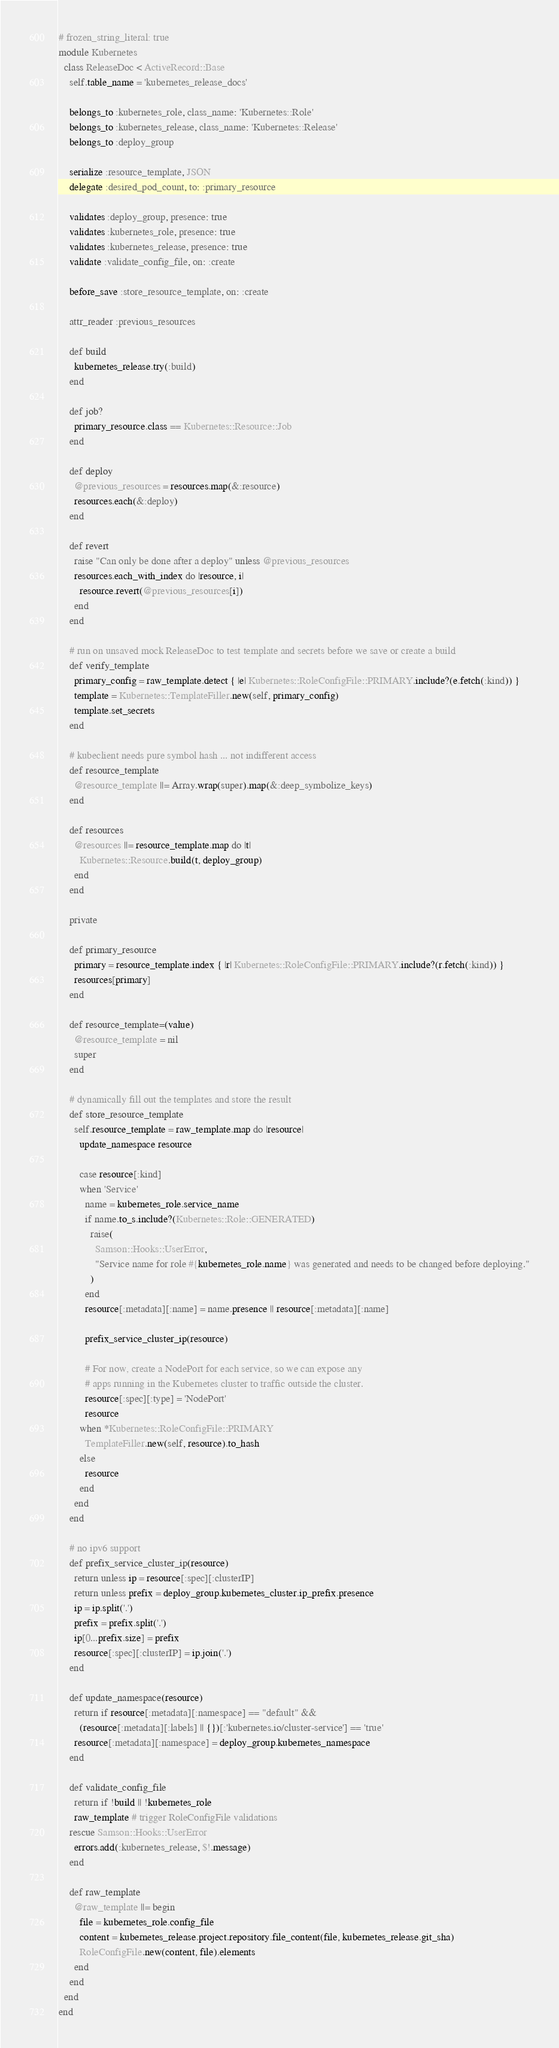Convert code to text. <code><loc_0><loc_0><loc_500><loc_500><_Ruby_># frozen_string_literal: true
module Kubernetes
  class ReleaseDoc < ActiveRecord::Base
    self.table_name = 'kubernetes_release_docs'

    belongs_to :kubernetes_role, class_name: 'Kubernetes::Role'
    belongs_to :kubernetes_release, class_name: 'Kubernetes::Release'
    belongs_to :deploy_group

    serialize :resource_template, JSON
    delegate :desired_pod_count, to: :primary_resource

    validates :deploy_group, presence: true
    validates :kubernetes_role, presence: true
    validates :kubernetes_release, presence: true
    validate :validate_config_file, on: :create

    before_save :store_resource_template, on: :create

    attr_reader :previous_resources

    def build
      kubernetes_release.try(:build)
    end

    def job?
      primary_resource.class == Kubernetes::Resource::Job
    end

    def deploy
      @previous_resources = resources.map(&:resource)
      resources.each(&:deploy)
    end

    def revert
      raise "Can only be done after a deploy" unless @previous_resources
      resources.each_with_index do |resource, i|
        resource.revert(@previous_resources[i])
      end
    end

    # run on unsaved mock ReleaseDoc to test template and secrets before we save or create a build
    def verify_template
      primary_config = raw_template.detect { |e| Kubernetes::RoleConfigFile::PRIMARY.include?(e.fetch(:kind)) }
      template = Kubernetes::TemplateFiller.new(self, primary_config)
      template.set_secrets
    end

    # kubeclient needs pure symbol hash ... not indifferent access
    def resource_template
      @resource_template ||= Array.wrap(super).map(&:deep_symbolize_keys)
    end

    def resources
      @resources ||= resource_template.map do |t|
        Kubernetes::Resource.build(t, deploy_group)
      end
    end

    private

    def primary_resource
      primary = resource_template.index { |r| Kubernetes::RoleConfigFile::PRIMARY.include?(r.fetch(:kind)) }
      resources[primary]
    end

    def resource_template=(value)
      @resource_template = nil
      super
    end

    # dynamically fill out the templates and store the result
    def store_resource_template
      self.resource_template = raw_template.map do |resource|
        update_namespace resource

        case resource[:kind]
        when 'Service'
          name = kubernetes_role.service_name
          if name.to_s.include?(Kubernetes::Role::GENERATED)
            raise(
              Samson::Hooks::UserError,
              "Service name for role #{kubernetes_role.name} was generated and needs to be changed before deploying."
            )
          end
          resource[:metadata][:name] = name.presence || resource[:metadata][:name]

          prefix_service_cluster_ip(resource)

          # For now, create a NodePort for each service, so we can expose any
          # apps running in the Kubernetes cluster to traffic outside the cluster.
          resource[:spec][:type] = 'NodePort'
          resource
        when *Kubernetes::RoleConfigFile::PRIMARY
          TemplateFiller.new(self, resource).to_hash
        else
          resource
        end
      end
    end

    # no ipv6 support
    def prefix_service_cluster_ip(resource)
      return unless ip = resource[:spec][:clusterIP]
      return unless prefix = deploy_group.kubernetes_cluster.ip_prefix.presence
      ip = ip.split('.')
      prefix = prefix.split('.')
      ip[0...prefix.size] = prefix
      resource[:spec][:clusterIP] = ip.join('.')
    end

    def update_namespace(resource)
      return if resource[:metadata][:namespace] == "default" &&
        (resource[:metadata][:labels] || {})[:'kubernetes.io/cluster-service'] == 'true'
      resource[:metadata][:namespace] = deploy_group.kubernetes_namespace
    end

    def validate_config_file
      return if !build || !kubernetes_role
      raw_template # trigger RoleConfigFile validations
    rescue Samson::Hooks::UserError
      errors.add(:kubernetes_release, $!.message)
    end

    def raw_template
      @raw_template ||= begin
        file = kubernetes_role.config_file
        content = kubernetes_release.project.repository.file_content(file, kubernetes_release.git_sha)
        RoleConfigFile.new(content, file).elements
      end
    end
  end
end
</code> 